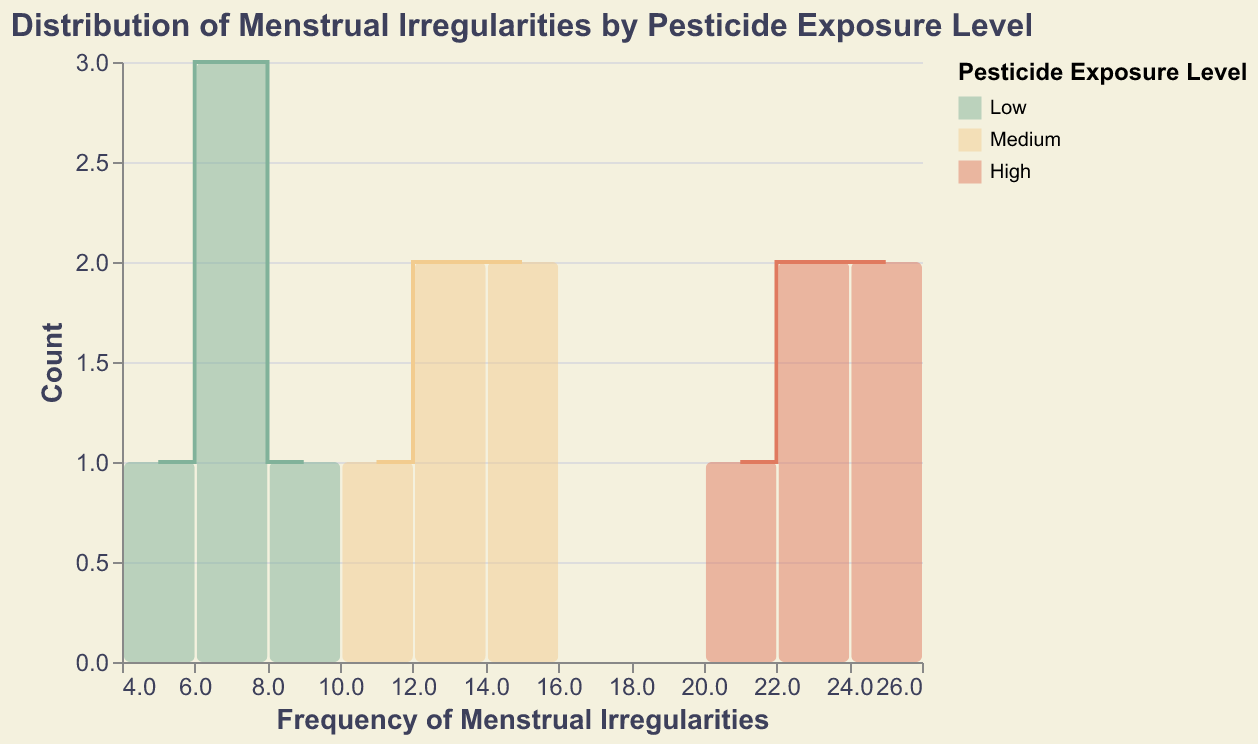What is the title of the plot? The title is located at the top of the plot to provide a clear context for what the figure represents.
Answer: Distribution of Menstrual Irregularities by Pesticide Exposure Level How many total exposure levels are presented in the plot? The legend on the right side of the plot indicates the different exposure levels.
Answer: Three (Low, Medium, High) Which color represents the "High" pesticide exposure level? The legend specifies the color associated with each pesticide exposure level.
Answer: Red What is the range of frequency values for the "Low" pesticide exposure level? By observing the horizontal axis and the range of the bars for the "Low" exposure level, we can determine the values. The "Low" level bars fall between 5 and 8.
Answer: 5 to 8 Which pesticide exposure level has the highest count of menstrual irregularities? Visual comparison of bar heights and line markers across all exposure levels reveals that the "High" exposure level has the highest bars and line peaks.
Answer: High What is the frequency value with the highest count for the "Medium" pesticide exposure level? For "Medium" levels, observing the highest point on the line and its corresponding frequency on the x-axis shows the maximum height at frequency 15.
Answer: 15 Compare the average frequency of menstrual irregularities for the "Low" and "High" pesticide exposure levels. Calculate the average for "Low" (5, 7, 6, 8, 6) = (5+7+6+8+6)/5 = 32/5 = 6.4, and for "High" (20, 23, 22, 24, 25) = (20+23+22+24+25)/5 = 114/5 = 22.8, then compare the averages.
Answer: Low: 6.4, High: 22.8 How does the frequency of menstrual irregularities change from "Medium" to "High" exposure levels? Examining the ranges and average frequencies for both levels, "Medium" ranges from 11 to 15, and "High" ranges from 20 to 25, indicating a significant increase in frequency with higher exposure.
Answer: Increases Which pesticide exposure level shows the least variation in the frequency of menstrual irregularities? By evaluating the spread of the frequency values within each category, it is evident that "Low" ranges from 5 to 8, showing the least variation.
Answer: Low What is the total count of data points for each exposure level? The bar heights and line points in each column summarize the number of data points. By counting these:
Low: 5,
Medium: 5,
High: 5
Answer: 5, 5, 5 